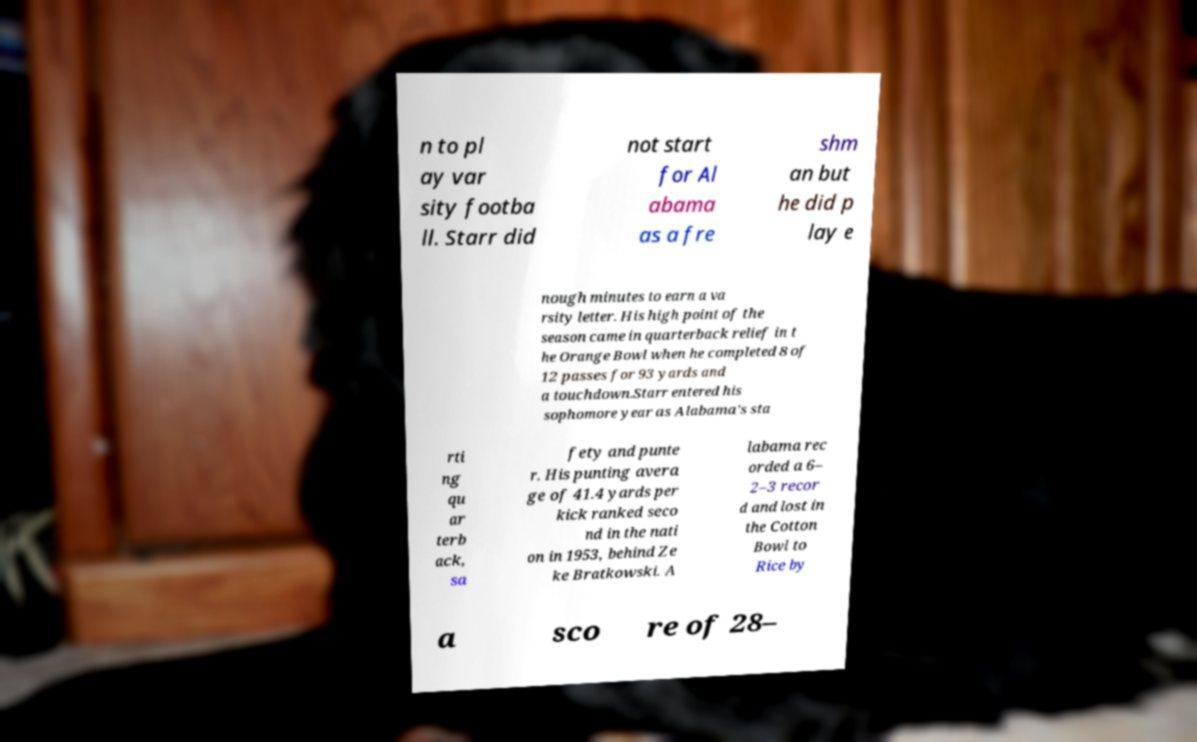I need the written content from this picture converted into text. Can you do that? n to pl ay var sity footba ll. Starr did not start for Al abama as a fre shm an but he did p lay e nough minutes to earn a va rsity letter. His high point of the season came in quarterback relief in t he Orange Bowl when he completed 8 of 12 passes for 93 yards and a touchdown.Starr entered his sophomore year as Alabama's sta rti ng qu ar terb ack, sa fety and punte r. His punting avera ge of 41.4 yards per kick ranked seco nd in the nati on in 1953, behind Ze ke Bratkowski. A labama rec orded a 6– 2–3 recor d and lost in the Cotton Bowl to Rice by a sco re of 28– 